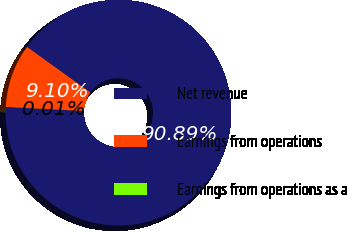<chart> <loc_0><loc_0><loc_500><loc_500><pie_chart><fcel>Net revenue<fcel>Earnings from operations<fcel>Earnings from operations as a<nl><fcel>90.89%<fcel>9.1%<fcel>0.01%<nl></chart> 